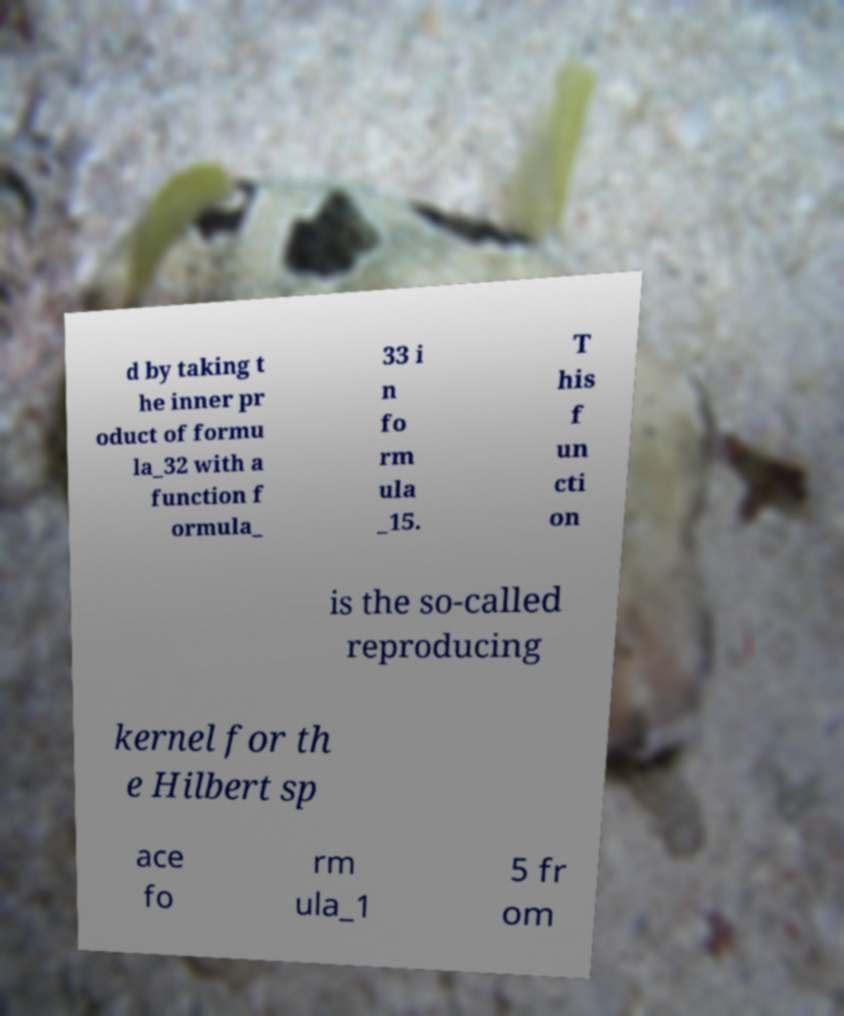Could you extract and type out the text from this image? d by taking t he inner pr oduct of formu la_32 with a function f ormula_ 33 i n fo rm ula _15. T his f un cti on is the so-called reproducing kernel for th e Hilbert sp ace fo rm ula_1 5 fr om 